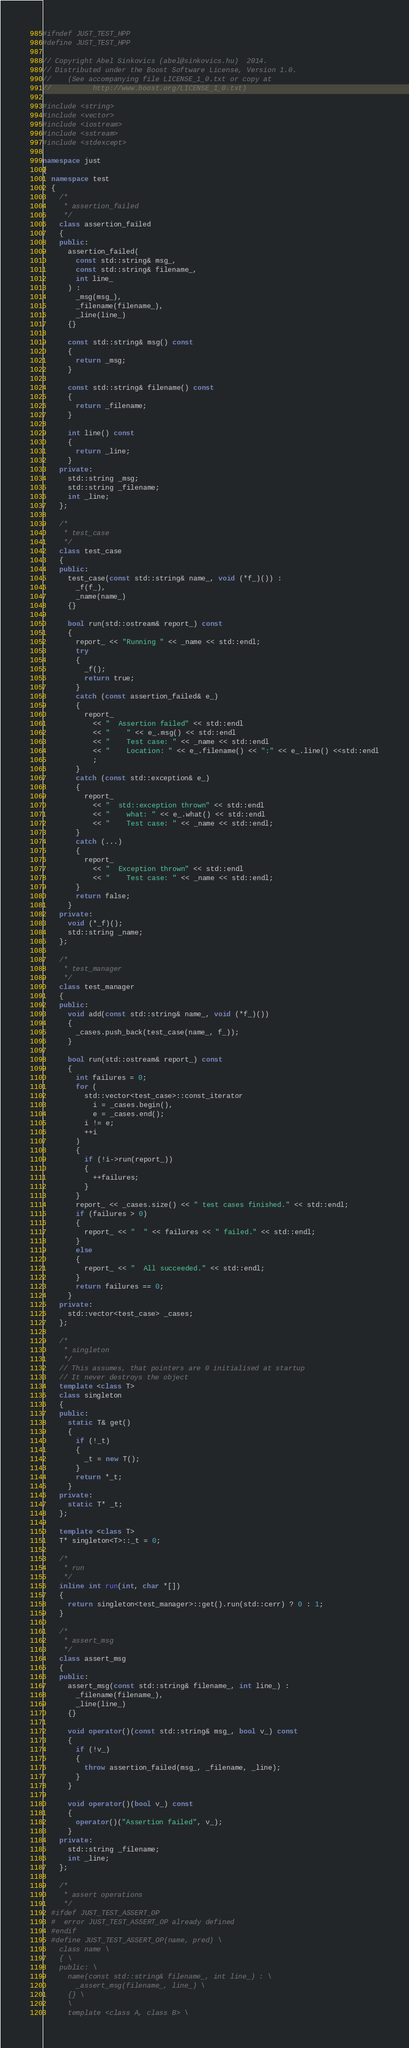<code> <loc_0><loc_0><loc_500><loc_500><_C++_>#ifndef JUST_TEST_HPP
#define JUST_TEST_HPP

// Copyright Abel Sinkovics (abel@sinkovics.hu)  2014.
// Distributed under the Boost Software License, Version 1.0.
//    (See accompanying file LICENSE_1_0.txt or copy at
//          http://www.boost.org/LICENSE_1_0.txt)

#include <string>
#include <vector>
#include <iostream>
#include <sstream>
#include <stdexcept>

namespace just
{
  namespace test
  {
    /*
     * assertion_failed
     */
    class assertion_failed
    {
    public:
      assertion_failed(
        const std::string& msg_,
        const std::string& filename_,
        int line_
      ) :
        _msg(msg_),
        _filename(filename_),
        _line(line_)
      {}

      const std::string& msg() const
      {
        return _msg;
      }

      const std::string& filename() const
      {
        return _filename;
      }

      int line() const
      {
        return _line;
      }
    private:
      std::string _msg;
      std::string _filename;
      int _line;
    };

    /*
     * test_case
     */
    class test_case
    {
    public:
      test_case(const std::string& name_, void (*f_)()) :
        _f(f_),
        _name(name_)
      {}

      bool run(std::ostream& report_) const
      {
        report_ << "Running " << _name << std::endl;
        try
        {
          _f();
          return true;
        }
        catch (const assertion_failed& e_)
        {
          report_
            << "  Assertion failed" << std::endl
            << "    " << e_.msg() << std::endl
            << "    Test case: " << _name << std::endl
            << "    Location: " << e_.filename() << ":" << e_.line() <<std::endl
            ;
        }
        catch (const std::exception& e_)
        {
          report_
            << "  std::exception thrown" << std::endl
            << "    what: " << e_.what() << std::endl
            << "    Test case: " << _name << std::endl;
        }
        catch (...)
        {
          report_
            << "  Exception thrown" << std::endl
            << "    Test case: " << _name << std::endl;
        }
        return false;
      }
    private:
      void (*_f)();
      std::string _name;
    };

    /*
     * test_manager
     */
    class test_manager
    {
    public:
      void add(const std::string& name_, void (*f_)())
      {
        _cases.push_back(test_case(name_, f_));
      }

      bool run(std::ostream& report_) const
      {
        int failures = 0;
        for (
          std::vector<test_case>::const_iterator
            i = _cases.begin(),
            e = _cases.end();
          i != e;
          ++i
        )
        {
          if (!i->run(report_))
          {
            ++failures;
          }
        }
        report_ << _cases.size() << " test cases finished." << std::endl;
        if (failures > 0)
        {
          report_ << "  " << failures << " failed." << std::endl;
        }
        else
        {
          report_ << "  All succeeded." << std::endl;
        }
        return failures == 0;
      }
    private:
      std::vector<test_case> _cases;
    };

    /*
     * singleton
     */
    // This assumes, that pointers are 0 initialised at startup
    // It never destroys the object
    template <class T>
    class singleton
    {
    public:
      static T& get()
      {
        if (!_t)
        {
          _t = new T();
        }
        return *_t;
      }
    private:
      static T* _t;
    };

    template <class T>
    T* singleton<T>::_t = 0;

    /*
     * run
     */
    inline int run(int, char *[])
    {
      return singleton<test_manager>::get().run(std::cerr) ? 0 : 1;
    }

    /*
     * assert_msg
     */
    class assert_msg
    {
    public:
      assert_msg(const std::string& filename_, int line_) :
        _filename(filename_),
        _line(line_)
      {}

      void operator()(const std::string& msg_, bool v_) const
      {
        if (!v_)
        {
          throw assertion_failed(msg_, _filename, _line);
        }
      }

      void operator()(bool v_) const
      {
        operator()("Assertion failed", v_);
      }
    private:
      std::string _filename;
      int _line;
    };

    /*
     * assert operations
     */
  #ifdef JUST_TEST_ASSERT_OP
  #  error JUST_TEST_ASSERT_OP already defined
  #endif
  #define JUST_TEST_ASSERT_OP(name, pred) \
    class name \
    { \
    public: \
      name(const std::string& filename_, int line_) : \
        _assert_msg(filename_, line_) \
      {} \
      \
      template <class A, class B> \</code> 